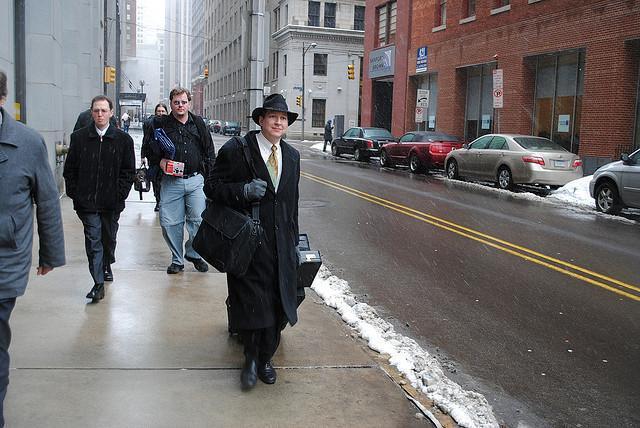How many people can be seen?
Give a very brief answer. 4. How many cars are there?
Give a very brief answer. 3. How many dogs are in the photo?
Give a very brief answer. 0. 